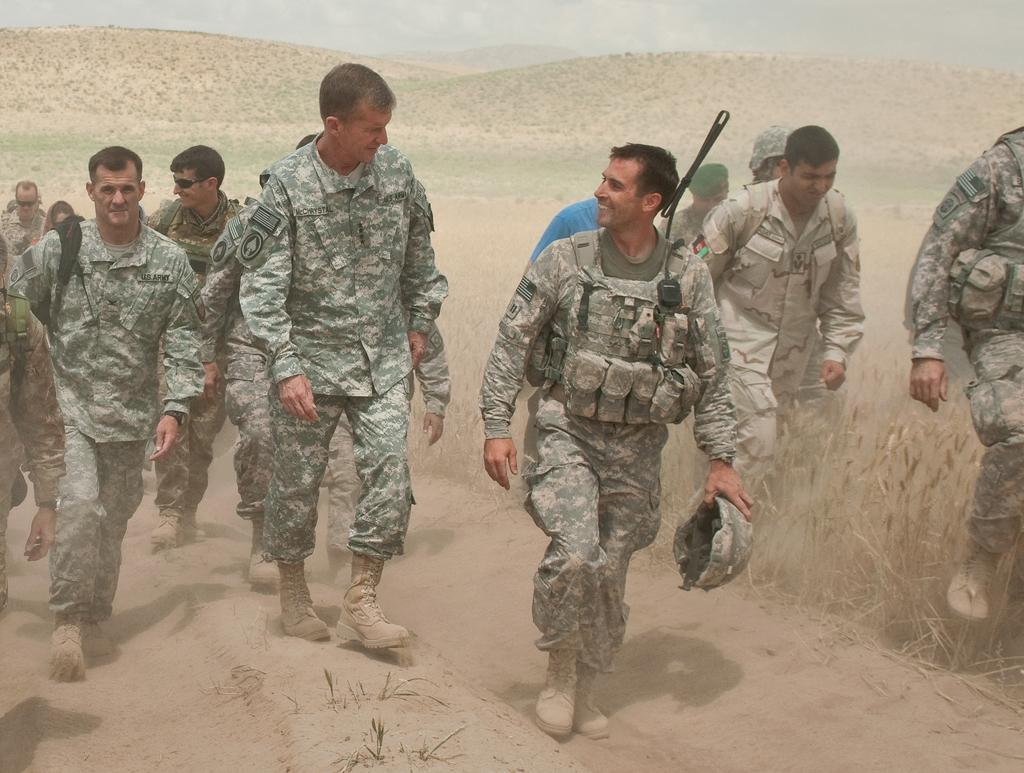What type of people are present in the image? There are army soldiers in the image. What are the soldiers doing in the image? The soldiers are walking on the right and left sides of the image. What can be seen in the background of the image? There is greenery in the background of the image. What type of clouds can be seen in the image? There are no clouds visible in the image; it features army soldiers walking and greenery in the background. 